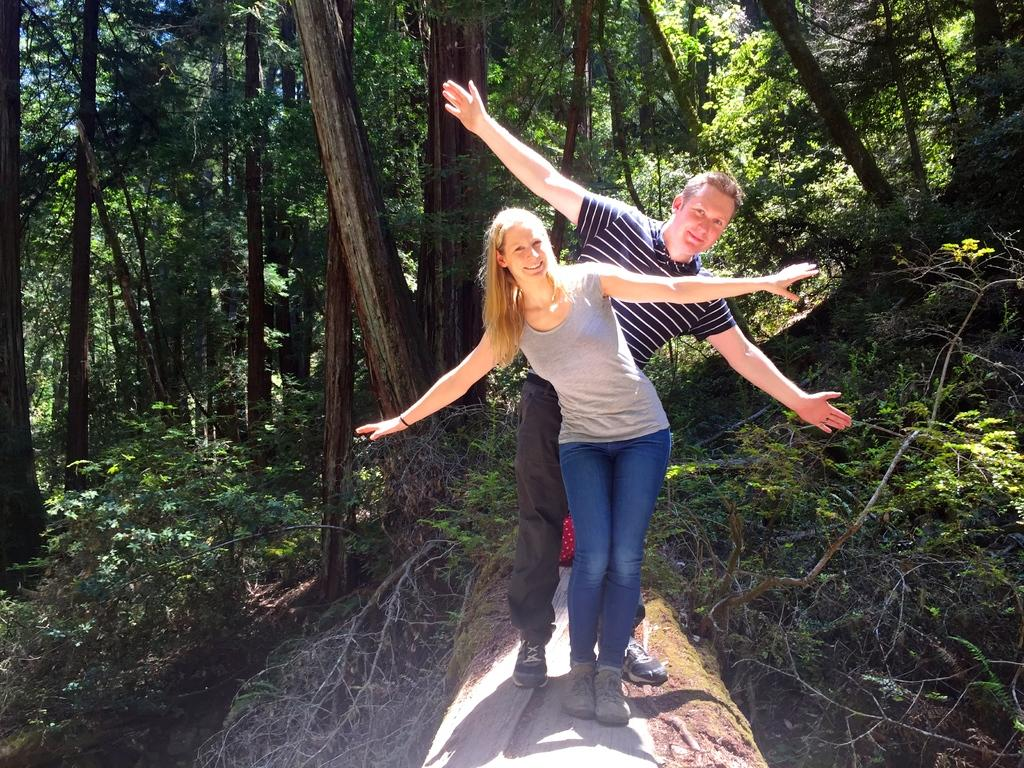How many people are present in the image? There are two people in the image. What can be seen in the background of the image? There are plants and trees in the background of the image. What color is the shirt of the person standing next to the stream in the image? There is no stream present in the image, and we cannot determine the color of anyone's shirt based on the provided facts. 